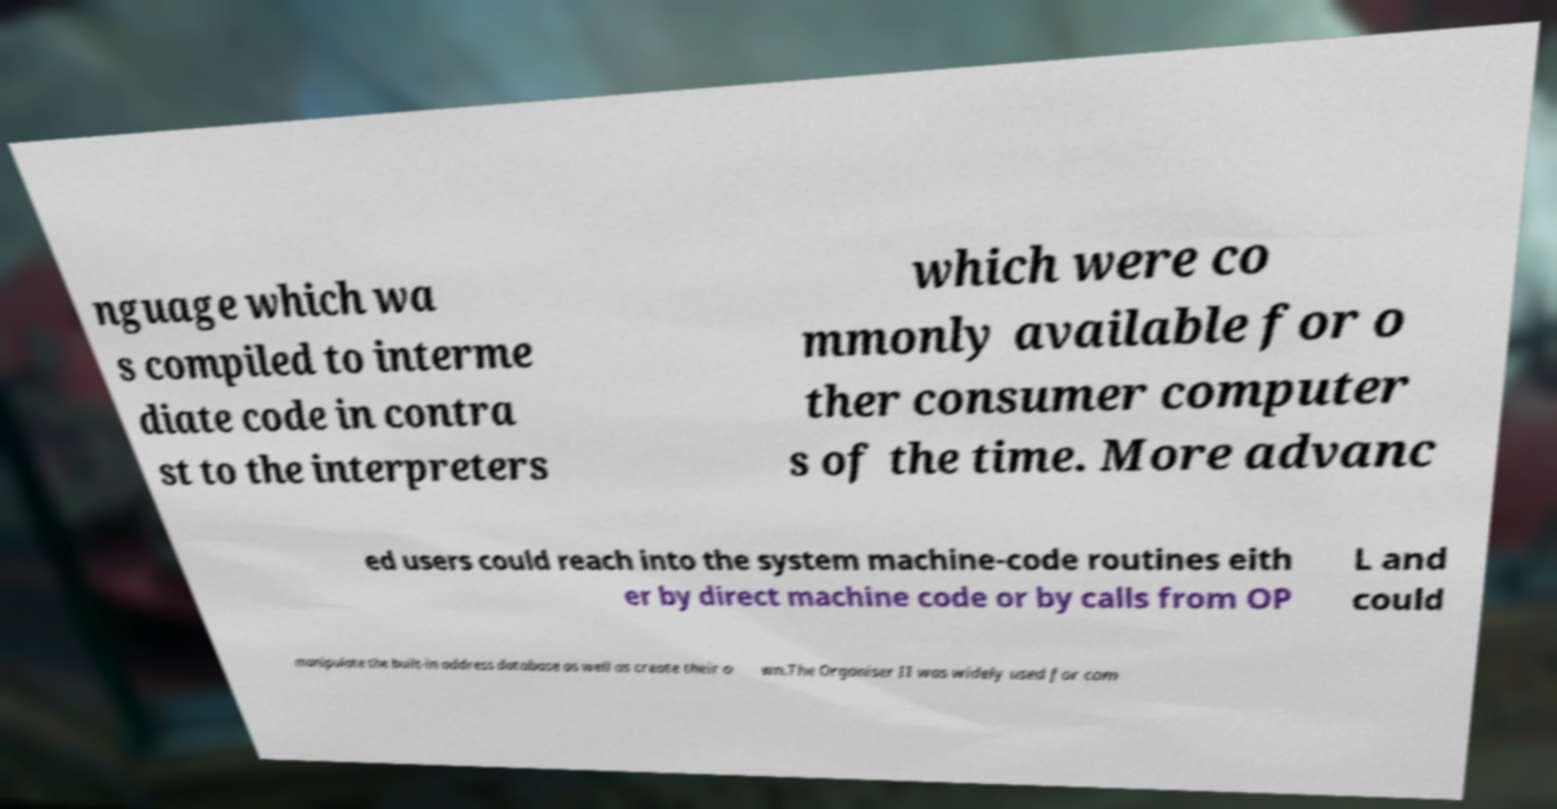Can you accurately transcribe the text from the provided image for me? nguage which wa s compiled to interme diate code in contra st to the interpreters which were co mmonly available for o ther consumer computer s of the time. More advanc ed users could reach into the system machine-code routines eith er by direct machine code or by calls from OP L and could manipulate the built-in address database as well as create their o wn.The Organiser II was widely used for com 